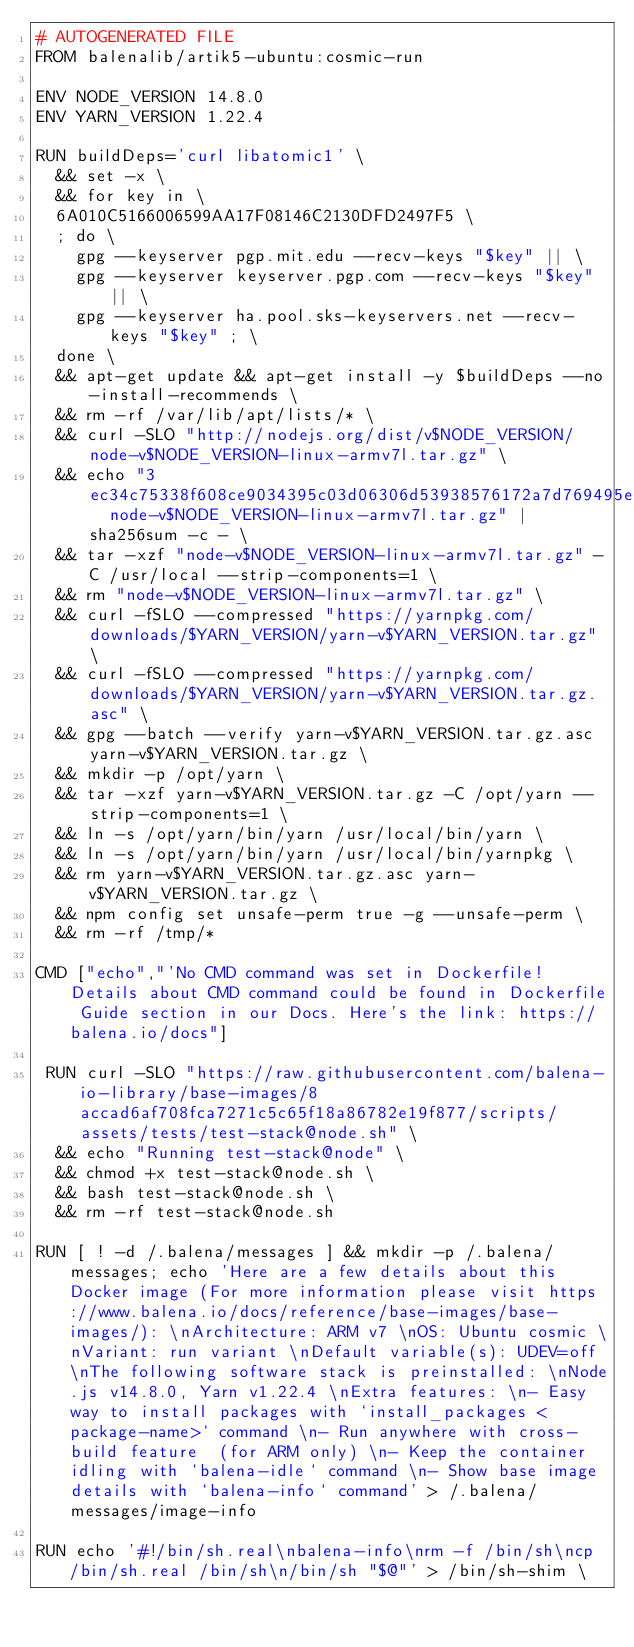Convert code to text. <code><loc_0><loc_0><loc_500><loc_500><_Dockerfile_># AUTOGENERATED FILE
FROM balenalib/artik5-ubuntu:cosmic-run

ENV NODE_VERSION 14.8.0
ENV YARN_VERSION 1.22.4

RUN buildDeps='curl libatomic1' \
	&& set -x \
	&& for key in \
	6A010C5166006599AA17F08146C2130DFD2497F5 \
	; do \
		gpg --keyserver pgp.mit.edu --recv-keys "$key" || \
		gpg --keyserver keyserver.pgp.com --recv-keys "$key" || \
		gpg --keyserver ha.pool.sks-keyservers.net --recv-keys "$key" ; \
	done \
	&& apt-get update && apt-get install -y $buildDeps --no-install-recommends \
	&& rm -rf /var/lib/apt/lists/* \
	&& curl -SLO "http://nodejs.org/dist/v$NODE_VERSION/node-v$NODE_VERSION-linux-armv7l.tar.gz" \
	&& echo "3ec34c75338f608ce9034395c03d06306d53938576172a7d769495ebf8ff512b  node-v$NODE_VERSION-linux-armv7l.tar.gz" | sha256sum -c - \
	&& tar -xzf "node-v$NODE_VERSION-linux-armv7l.tar.gz" -C /usr/local --strip-components=1 \
	&& rm "node-v$NODE_VERSION-linux-armv7l.tar.gz" \
	&& curl -fSLO --compressed "https://yarnpkg.com/downloads/$YARN_VERSION/yarn-v$YARN_VERSION.tar.gz" \
	&& curl -fSLO --compressed "https://yarnpkg.com/downloads/$YARN_VERSION/yarn-v$YARN_VERSION.tar.gz.asc" \
	&& gpg --batch --verify yarn-v$YARN_VERSION.tar.gz.asc yarn-v$YARN_VERSION.tar.gz \
	&& mkdir -p /opt/yarn \
	&& tar -xzf yarn-v$YARN_VERSION.tar.gz -C /opt/yarn --strip-components=1 \
	&& ln -s /opt/yarn/bin/yarn /usr/local/bin/yarn \
	&& ln -s /opt/yarn/bin/yarn /usr/local/bin/yarnpkg \
	&& rm yarn-v$YARN_VERSION.tar.gz.asc yarn-v$YARN_VERSION.tar.gz \
	&& npm config set unsafe-perm true -g --unsafe-perm \
	&& rm -rf /tmp/*

CMD ["echo","'No CMD command was set in Dockerfile! Details about CMD command could be found in Dockerfile Guide section in our Docs. Here's the link: https://balena.io/docs"]

 RUN curl -SLO "https://raw.githubusercontent.com/balena-io-library/base-images/8accad6af708fca7271c5c65f18a86782e19f877/scripts/assets/tests/test-stack@node.sh" \
  && echo "Running test-stack@node" \
  && chmod +x test-stack@node.sh \
  && bash test-stack@node.sh \
  && rm -rf test-stack@node.sh 

RUN [ ! -d /.balena/messages ] && mkdir -p /.balena/messages; echo 'Here are a few details about this Docker image (For more information please visit https://www.balena.io/docs/reference/base-images/base-images/): \nArchitecture: ARM v7 \nOS: Ubuntu cosmic \nVariant: run variant \nDefault variable(s): UDEV=off \nThe following software stack is preinstalled: \nNode.js v14.8.0, Yarn v1.22.4 \nExtra features: \n- Easy way to install packages with `install_packages <package-name>` command \n- Run anywhere with cross-build feature  (for ARM only) \n- Keep the container idling with `balena-idle` command \n- Show base image details with `balena-info` command' > /.balena/messages/image-info

RUN echo '#!/bin/sh.real\nbalena-info\nrm -f /bin/sh\ncp /bin/sh.real /bin/sh\n/bin/sh "$@"' > /bin/sh-shim \</code> 